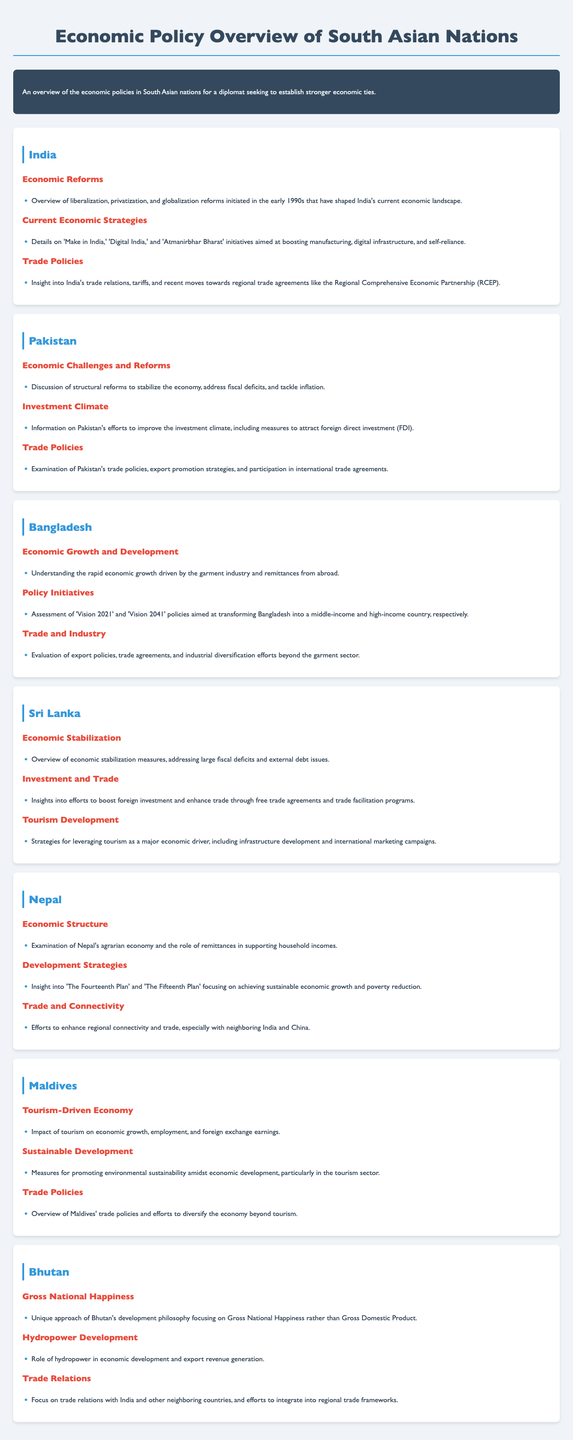What economic initiative is aimed at enhancing manufacturing in India? 'Make in India' is one of the key initiatives aimed at boosting manufacturing in India.
Answer: 'Make in India' What is Bhutan's development philosophy focused on? Bhutan's development philosophy emphasizes Gross National Happiness over traditional economic measures like Gross Domestic Product.
Answer: Gross National Happiness Which country has a tourism-driven economy? The Maldives is notable for its economy being heavily reliant on tourism.
Answer: Maldives What plan does Nepal follow to achieve sustainable economic growth? Nepal focuses on 'The Fourteenth Plan' and 'The Fifteenth Plan' for sustainable economic growth.
Answer: 'The Fourteenth Plan' and 'The Fifteenth Plan' Which economic sector is Sri Lanka trying to leverage as a major driver? Sri Lanka is focusing on tourism development as a significant contributor to its economy.
Answer: Tourism What are Bangladesh's long-term policy visions? Bangladesh has two long-term policy initiatives referred to as 'Vision 2021' and 'Vision 2041'.
Answer: 'Vision 2021' and 'Vision 2041' What economic reform did India initiate in the early 1990s? India's economic landscape was significantly shaped by liberalization, privatization, and globalization reforms initiated in the early 1990s.
Answer: Liberalization, privatization, and globalization reforms What measures does Pakistan adopt to improve its investment climate? Pakistan has implemented measures to attract foreign direct investment (FDI) to enhance its investment climate.
Answer: Measures to attract foreign direct investment (FDI) Which country is recognized for its robust garment industry? Bangladesh is recognized for its rapid economic growth driven by the garment industry.
Answer: Bangladesh 